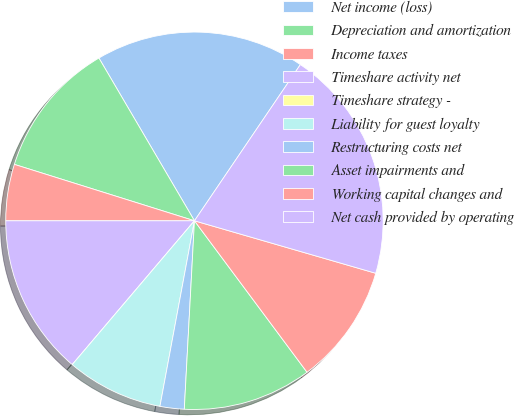Convert chart. <chart><loc_0><loc_0><loc_500><loc_500><pie_chart><fcel>Net income (loss)<fcel>Depreciation and amortization<fcel>Income taxes<fcel>Timeshare activity net<fcel>Timeshare strategy -<fcel>Liability for guest loyalty<fcel>Restructuring costs net<fcel>Asset impairments and<fcel>Working capital changes and<fcel>Net cash provided by operating<nl><fcel>17.93%<fcel>11.72%<fcel>4.83%<fcel>13.79%<fcel>0.0%<fcel>8.28%<fcel>2.07%<fcel>11.03%<fcel>10.34%<fcel>20.0%<nl></chart> 